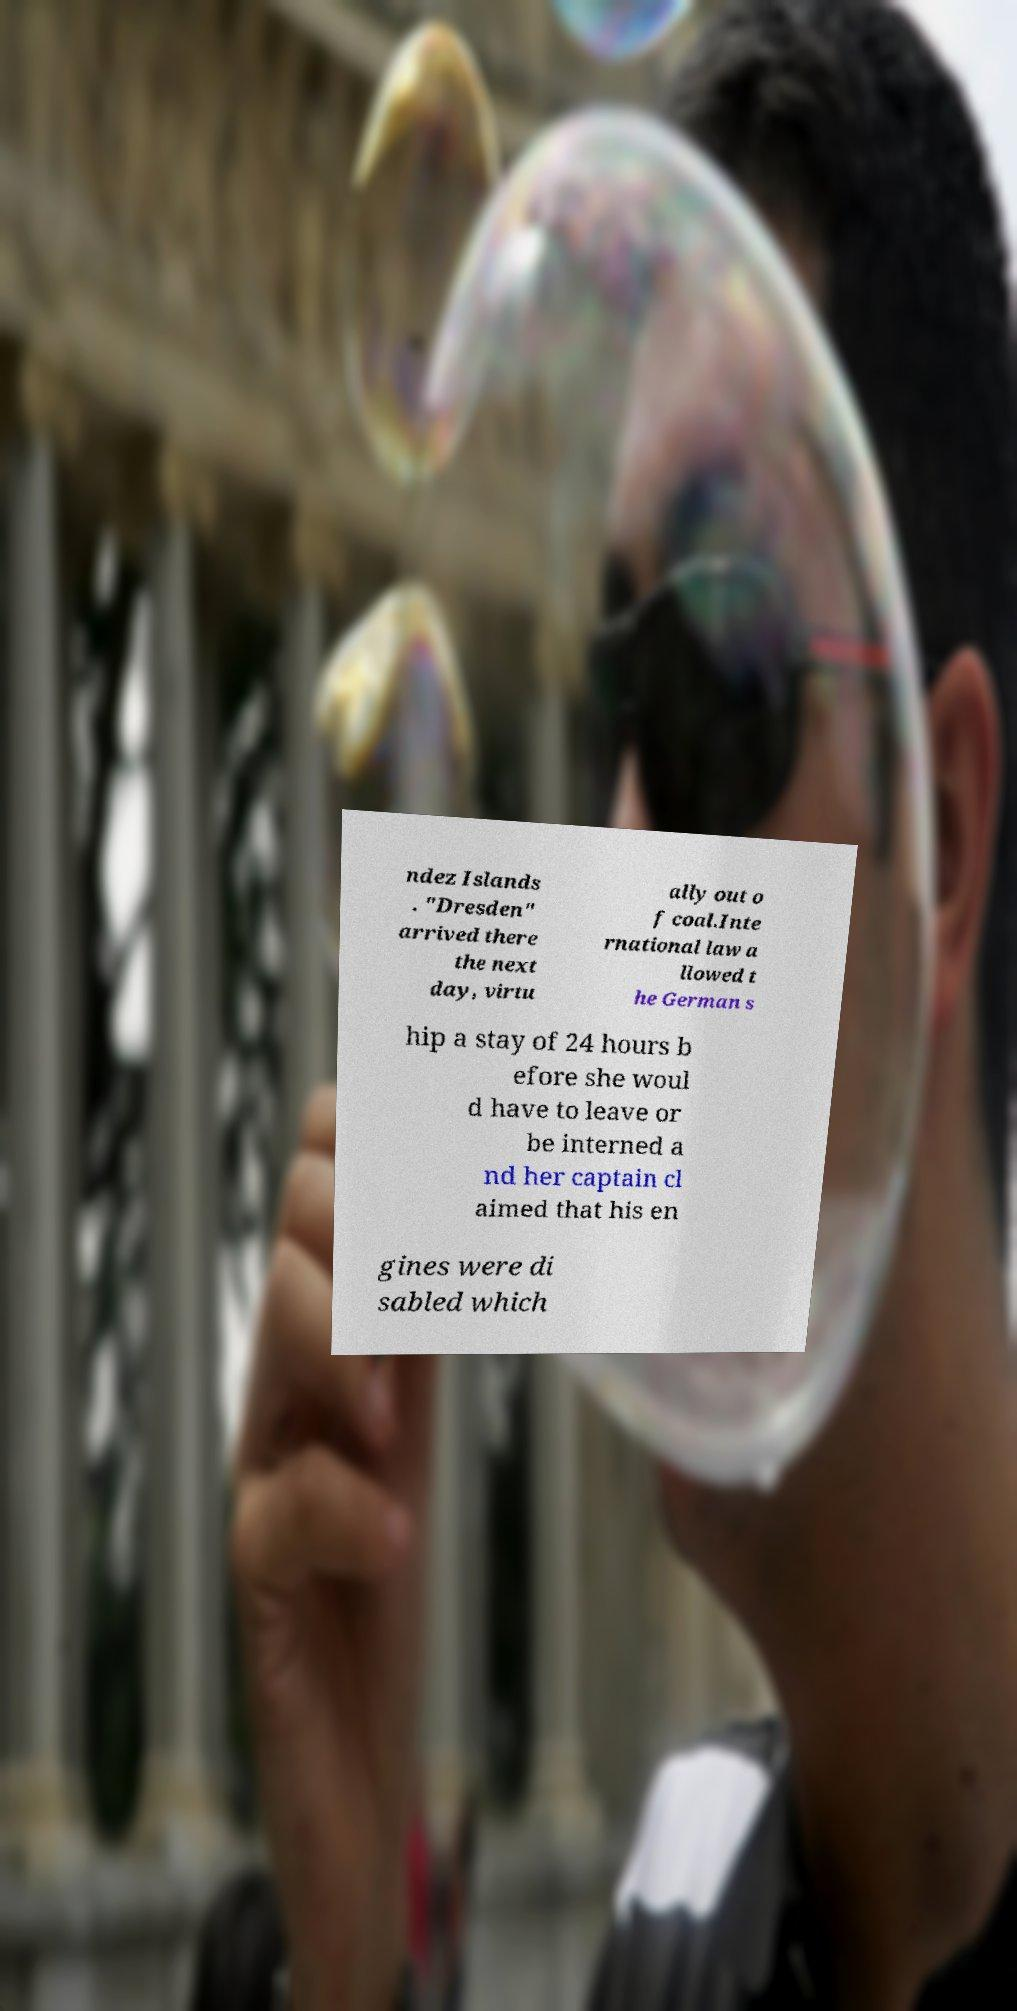Can you accurately transcribe the text from the provided image for me? ndez Islands . "Dresden" arrived there the next day, virtu ally out o f coal.Inte rnational law a llowed t he German s hip a stay of 24 hours b efore she woul d have to leave or be interned a nd her captain cl aimed that his en gines were di sabled which 